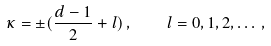Convert formula to latex. <formula><loc_0><loc_0><loc_500><loc_500>\kappa = \pm ( \frac { d - 1 } { 2 } + l ) \, , \quad l = 0 , 1 , 2 , \dots \, ,</formula> 